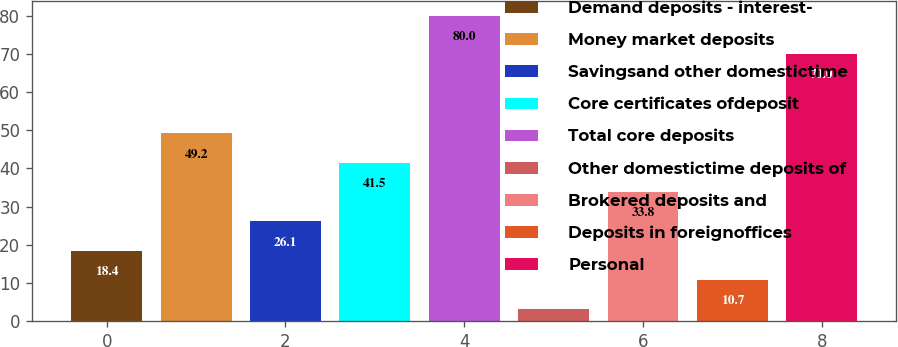<chart> <loc_0><loc_0><loc_500><loc_500><bar_chart><fcel>Demand deposits - interest-<fcel>Money market deposits<fcel>Savingsand other domestictime<fcel>Core certificates ofdeposit<fcel>Total core deposits<fcel>Other domestictime deposits of<fcel>Brokered deposits and<fcel>Deposits in foreignoffices<fcel>Personal<nl><fcel>18.4<fcel>49.2<fcel>26.1<fcel>41.5<fcel>80<fcel>3<fcel>33.8<fcel>10.7<fcel>70<nl></chart> 